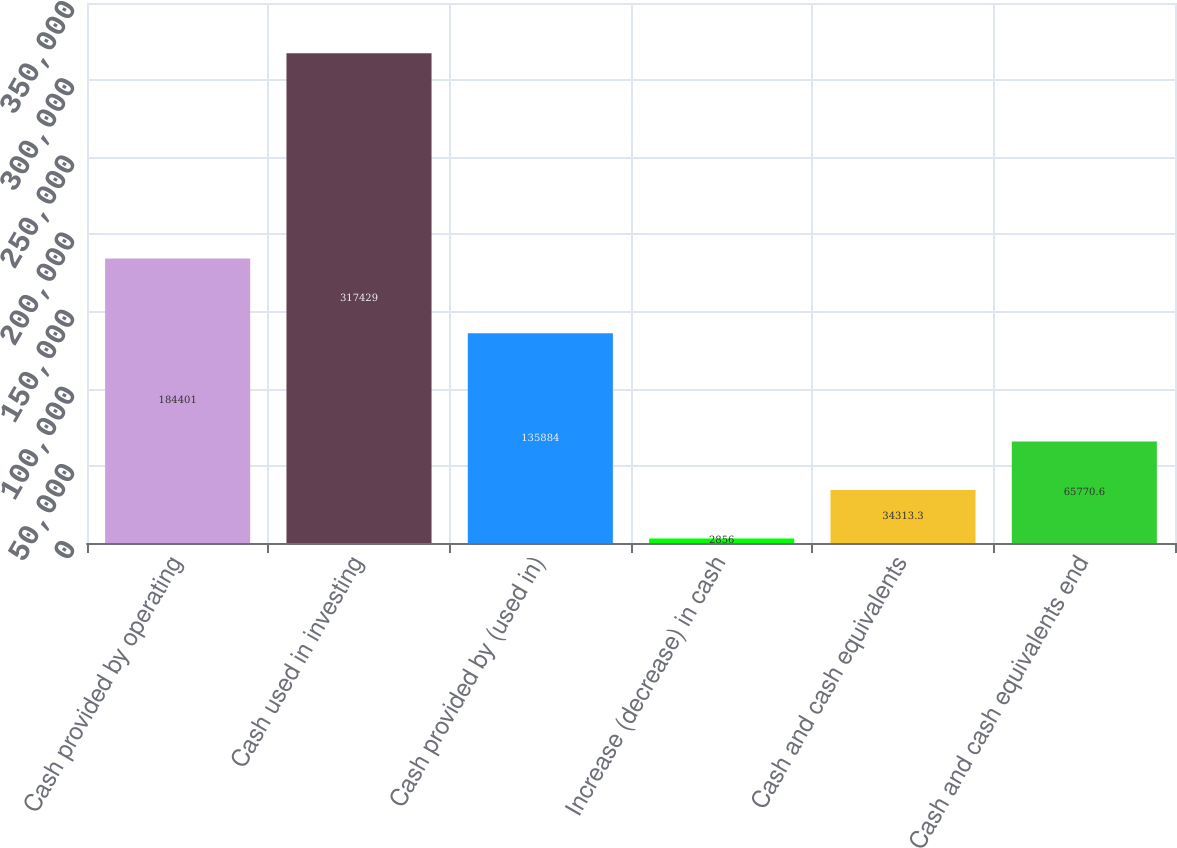<chart> <loc_0><loc_0><loc_500><loc_500><bar_chart><fcel>Cash provided by operating<fcel>Cash used in investing<fcel>Cash provided by (used in)<fcel>Increase (decrease) in cash<fcel>Cash and cash equivalents<fcel>Cash and cash equivalents end<nl><fcel>184401<fcel>317429<fcel>135884<fcel>2856<fcel>34313.3<fcel>65770.6<nl></chart> 